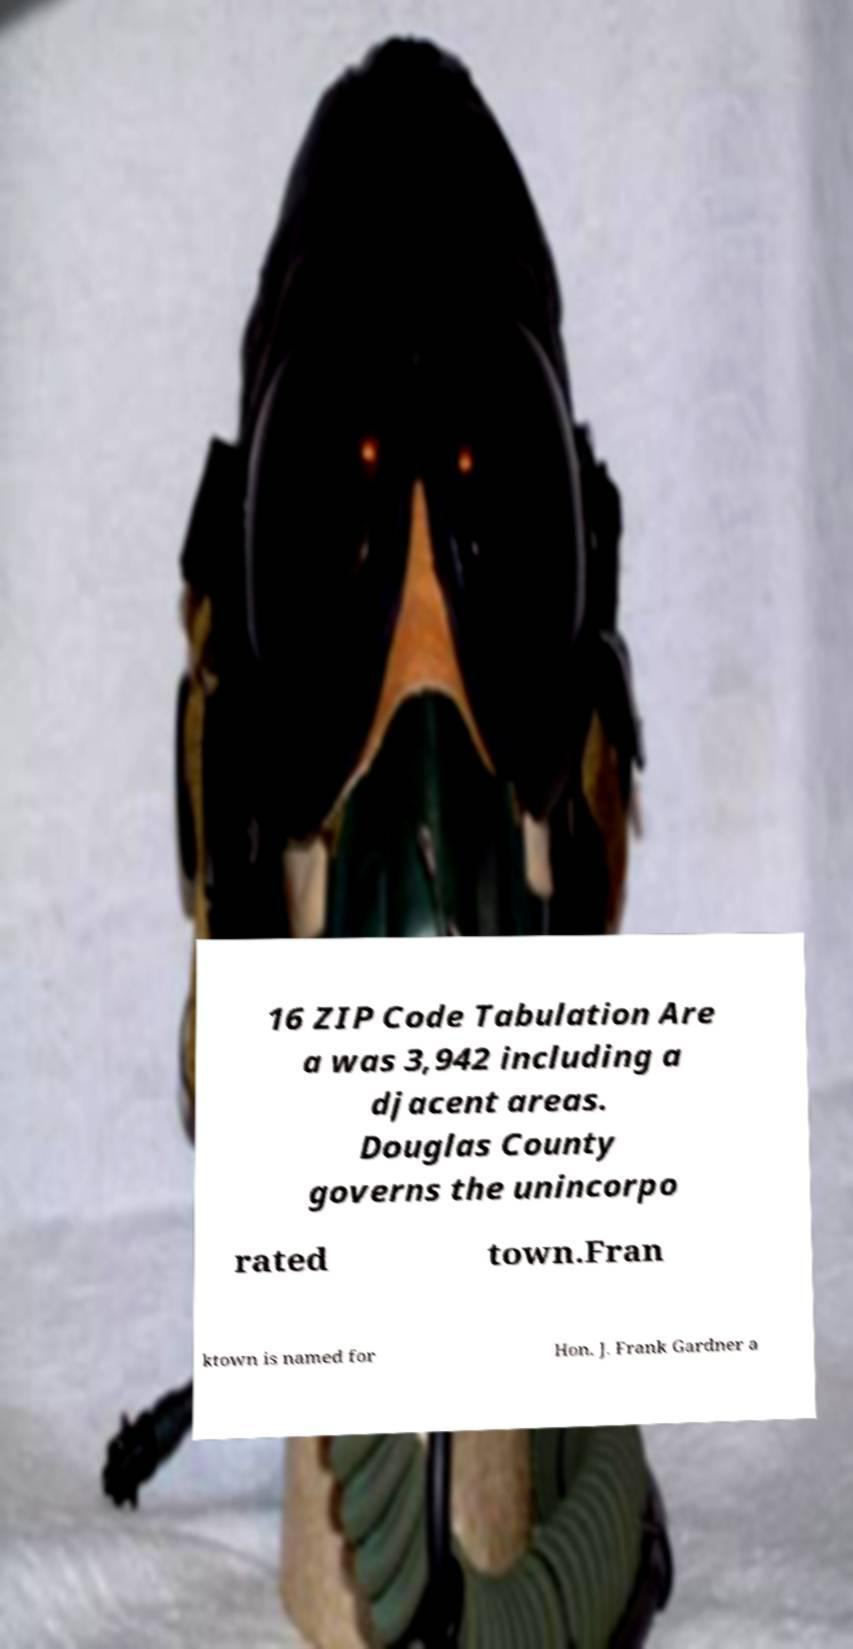Could you assist in decoding the text presented in this image and type it out clearly? 16 ZIP Code Tabulation Are a was 3,942 including a djacent areas. Douglas County governs the unincorpo rated town.Fran ktown is named for Hon. J. Frank Gardner a 